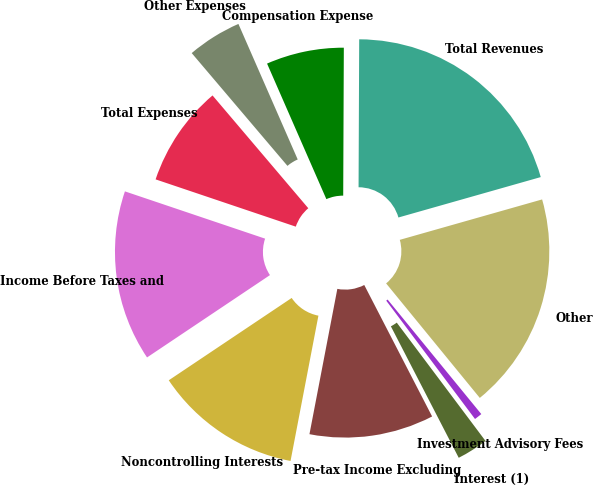<chart> <loc_0><loc_0><loc_500><loc_500><pie_chart><fcel>Interest (1)<fcel>Investment Advisory Fees<fcel>Other<fcel>Total Revenues<fcel>Compensation Expense<fcel>Other Expenses<fcel>Total Expenses<fcel>Income Before Taxes and<fcel>Noncontrolling Interests<fcel>Pre-tax Income Excluding<nl><fcel>2.66%<fcel>0.67%<fcel>18.49%<fcel>20.53%<fcel>6.63%<fcel>4.64%<fcel>8.62%<fcel>14.57%<fcel>12.59%<fcel>10.6%<nl></chart> 